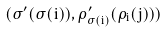Convert formula to latex. <formula><loc_0><loc_0><loc_500><loc_500>( \sigma ^ { \prime } ( \sigma ( i ) ) , \rho _ { \sigma ( i ) } ^ { \prime } ( \rho _ { i } ( j ) ) )</formula> 